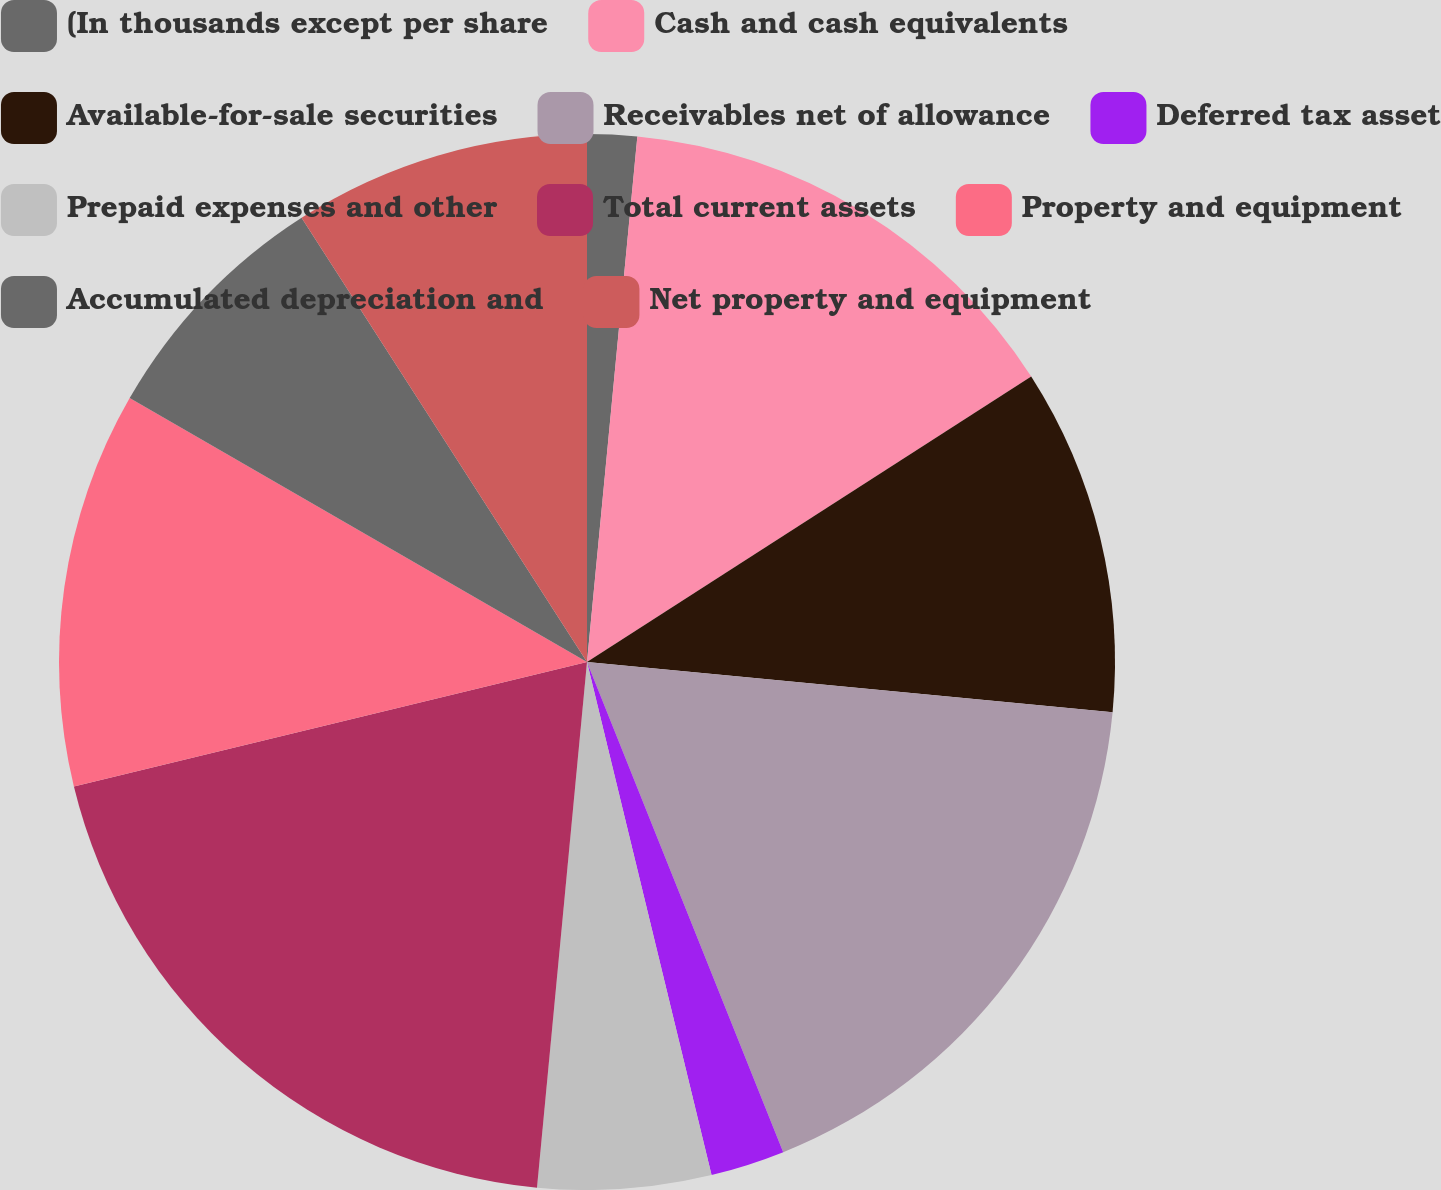Convert chart to OTSL. <chart><loc_0><loc_0><loc_500><loc_500><pie_chart><fcel>(In thousands except per share<fcel>Cash and cash equivalents<fcel>Available-for-sale securities<fcel>Receivables net of allowance<fcel>Deferred tax asset<fcel>Prepaid expenses and other<fcel>Total current assets<fcel>Property and equipment<fcel>Accumulated depreciation and<fcel>Net property and equipment<nl><fcel>1.52%<fcel>14.39%<fcel>10.61%<fcel>17.42%<fcel>2.27%<fcel>5.3%<fcel>19.7%<fcel>12.12%<fcel>7.58%<fcel>9.09%<nl></chart> 